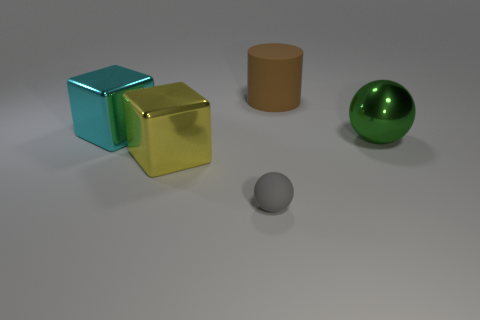Add 4 tiny red shiny cubes. How many objects exist? 9 Subtract all blocks. How many objects are left? 3 Add 3 green shiny cubes. How many green shiny cubes exist? 3 Subtract 0 cyan balls. How many objects are left? 5 Subtract all yellow matte cubes. Subtract all large cyan shiny things. How many objects are left? 4 Add 1 big cyan shiny things. How many big cyan shiny things are left? 2 